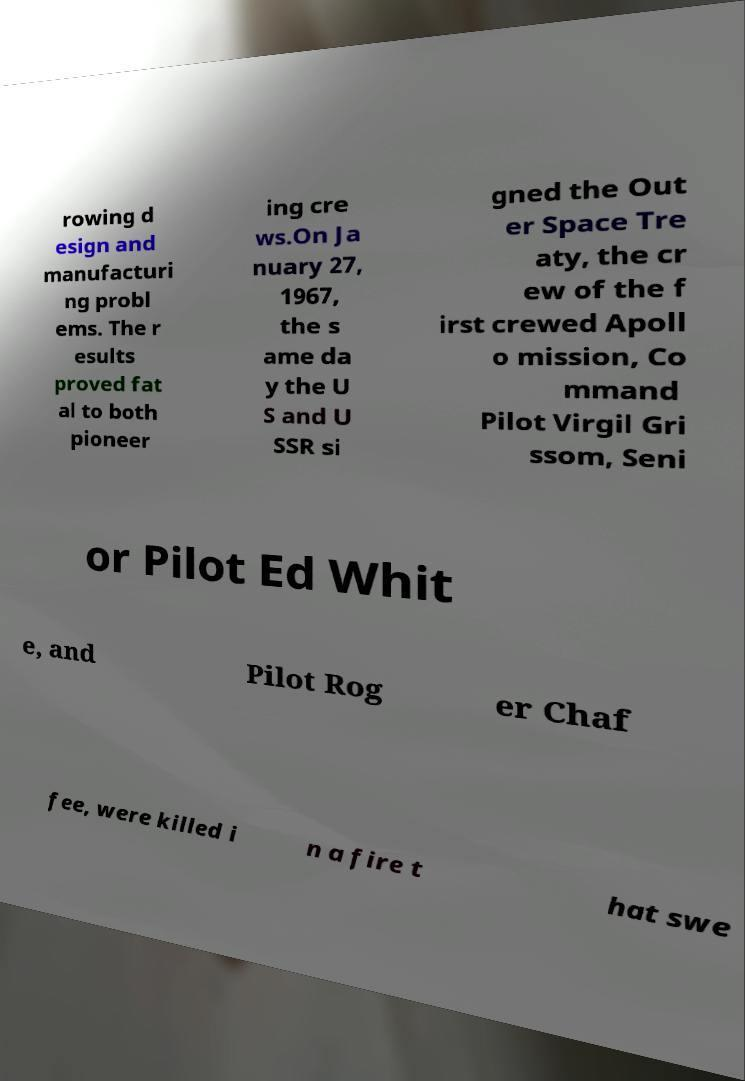Please read and relay the text visible in this image. What does it say? rowing d esign and manufacturi ng probl ems. The r esults proved fat al to both pioneer ing cre ws.On Ja nuary 27, 1967, the s ame da y the U S and U SSR si gned the Out er Space Tre aty, the cr ew of the f irst crewed Apoll o mission, Co mmand Pilot Virgil Gri ssom, Seni or Pilot Ed Whit e, and Pilot Rog er Chaf fee, were killed i n a fire t hat swe 